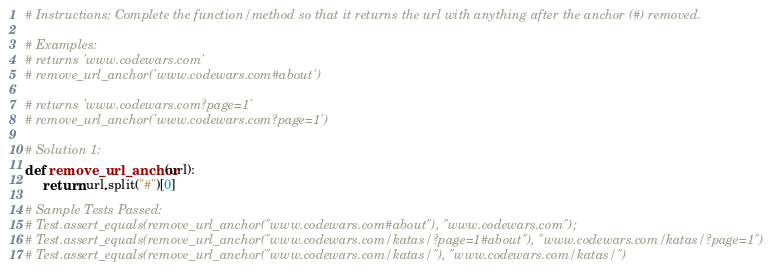<code> <loc_0><loc_0><loc_500><loc_500><_Python_># Instructions: Complete the function/method so that it returns the url with anything after the anchor (#) removed.

# Examples:
# returns 'www.codewars.com'
# remove_url_anchor('www.codewars.com#about')

# returns 'www.codewars.com?page=1' 
# remove_url_anchor('www.codewars.com?page=1')

# Solution 1:
def remove_url_anchor(url):
     return url.split("#")[0]

# Sample Tests Passed:
# Test.assert_equals(remove_url_anchor("www.codewars.com#about"), "www.codewars.com");
# Test.assert_equals(remove_url_anchor("www.codewars.com/katas/?page=1#about"), "www.codewars.com/katas/?page=1")
# Test.assert_equals(remove_url_anchor("www.codewars.com/katas/"), "www.codewars.com/katas/")</code> 